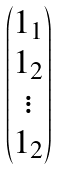Convert formula to latex. <formula><loc_0><loc_0><loc_500><loc_500>\begin{pmatrix} 1 _ { 1 } \\ 1 _ { 2 } \\ \vdots \\ 1 _ { 2 } \end{pmatrix}</formula> 